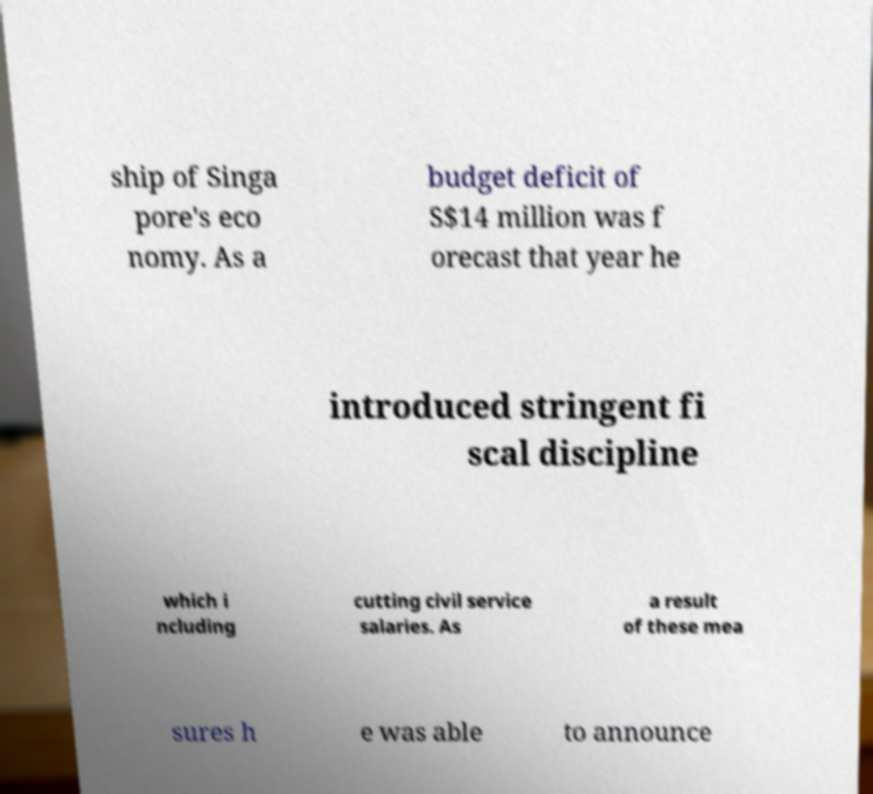Please read and relay the text visible in this image. What does it say? ship of Singa pore's eco nomy. As a budget deficit of S$14 million was f orecast that year he introduced stringent fi scal discipline which i ncluding cutting civil service salaries. As a result of these mea sures h e was able to announce 